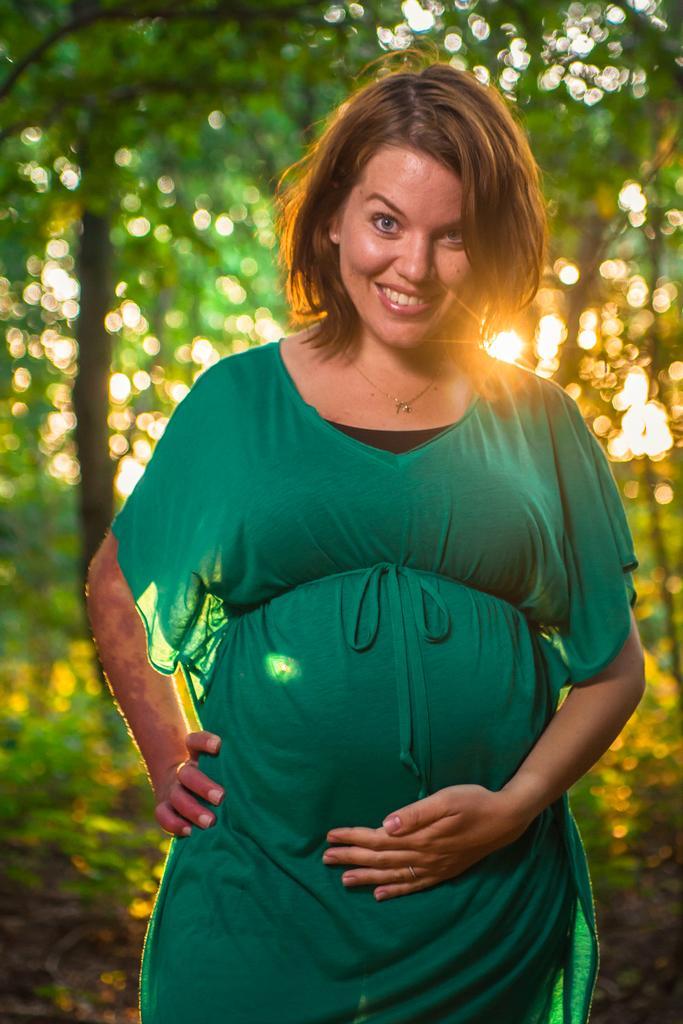Can you describe this image briefly? In this image we can see a woman smiling and posing for a photo and we can see some trees and the sunlight in the background. 